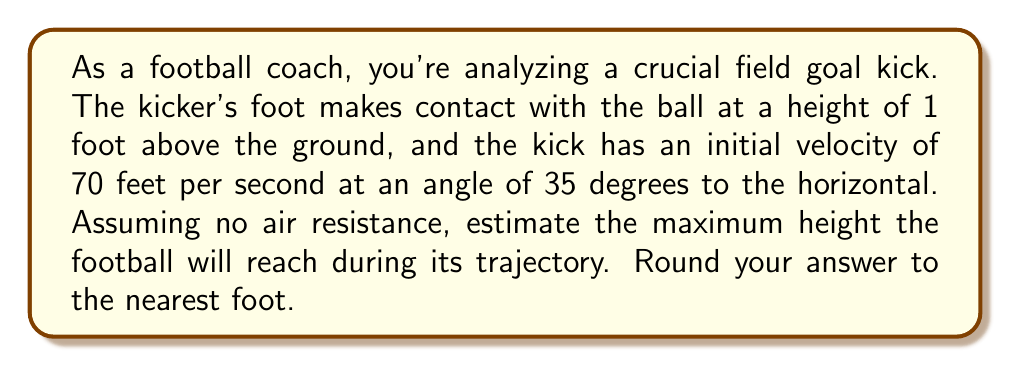Can you answer this question? Let's approach this step-by-step using trigonometric functions and the equations of projectile motion:

1) First, we need to break down the initial velocity into its vertical and horizontal components:

   $v_x = v \cos \theta = 70 \cos 35° \approx 57.32 \text{ ft/s}$
   $v_y = v \sin \theta = 70 \sin 35° \approx 40.11 \text{ ft/s}$

2) The maximum height is reached when the vertical velocity becomes zero. We can use the equation:

   $v_y^2 = v_{y0}^2 - 2g(y - y_0)$

   Where $v_y$ is the final vertical velocity (0 at the highest point), $v_{y0}$ is the initial vertical velocity, $g$ is the acceleration due to gravity (32 ft/s²), $y$ is the maximum height, and $y_0$ is the initial height.

3) Substituting our known values:

   $0^2 = 40.11^2 - 2(32)(y - 1)$

4) Solving for $y$:

   $0 = 1608.81 - 64(y - 1)$
   $64y - 64 = 1608.81$
   $64y = 1672.81$
   $y = 26.14 \text{ ft}$

5) However, this is the height above the initial position. To get the total height, we need to add the initial height of 1 foot:

   $26.14 + 1 = 27.14 \text{ ft}$

6) Rounding to the nearest foot:

   $27.14 \approx 27 \text{ ft}$
Answer: The maximum height the football will reach during its trajectory is approximately 27 feet. 